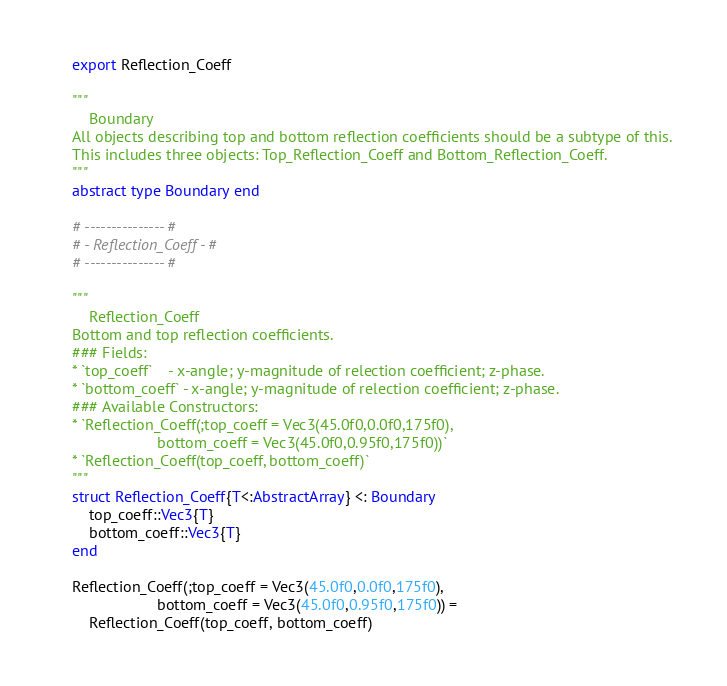Convert code to text. <code><loc_0><loc_0><loc_500><loc_500><_Julia_>export Reflection_Coeff

"""
    Boundary
All objects describing top and bottom reflection coefficients should be a subtype of this.
This includes three objects: Top_Reflection_Coeff and Bottom_Reflection_Coeff.
"""
abstract type Boundary end

# --------------- #
# - Reflection_Coeff - #
# --------------- #

"""
    Reflection_Coeff
Bottom and top reflection coefficients.
### Fields:
* `top_coeff`    - x-angle; y-magnitude of relection coefficient; z-phase.
* `bottom_coeff` - x-angle; y-magnitude of relection coefficient; z-phase.
### Available Constructors:
* `Reflection_Coeff(;top_coeff = Vec3(45.0f0,0.0f0,175f0),
                    bottom_coeff = Vec3(45.0f0,0.95f0,175f0))`
* `Reflection_Coeff(top_coeff, bottom_coeff)`
"""
struct Reflection_Coeff{T<:AbstractArray} <: Boundary
    top_coeff::Vec3{T}
    bottom_coeff::Vec3{T}
end

Reflection_Coeff(;top_coeff = Vec3(45.0f0,0.0f0,175f0),
                    bottom_coeff = Vec3(45.0f0,0.95f0,175f0)) =
    Reflection_Coeff(top_coeff, bottom_coeff)
</code> 